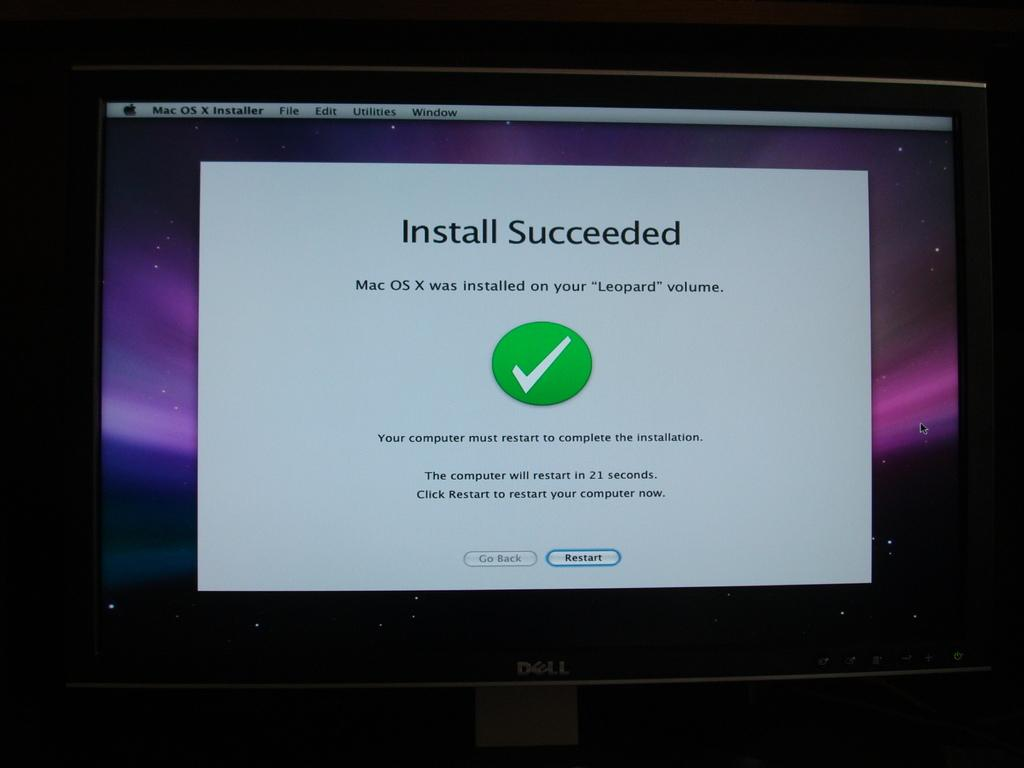Provide a one-sentence caption for the provided image. Dell computer monitor letting the user know the Install Succeeded. 